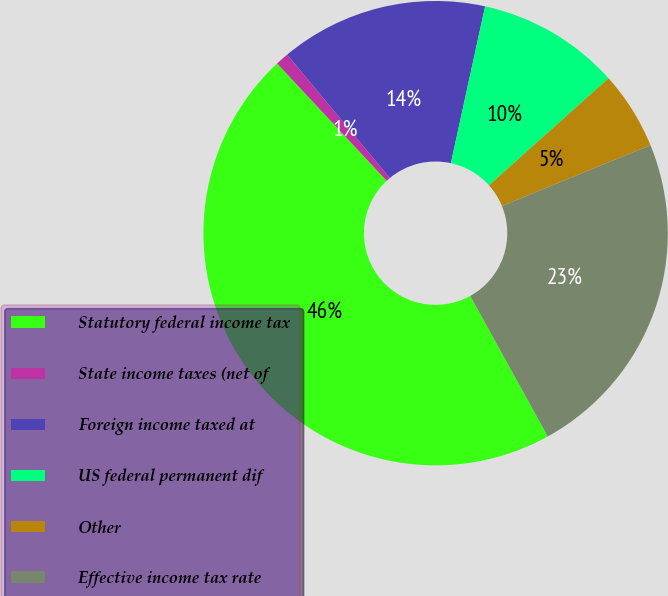Convert chart. <chart><loc_0><loc_0><loc_500><loc_500><pie_chart><fcel>Statutory federal income tax<fcel>State income taxes (net of<fcel>Foreign income taxed at<fcel>US federal permanent dif<fcel>Other<fcel>Effective income tax rate<nl><fcel>46.06%<fcel>0.92%<fcel>14.46%<fcel>9.95%<fcel>5.44%<fcel>23.16%<nl></chart> 